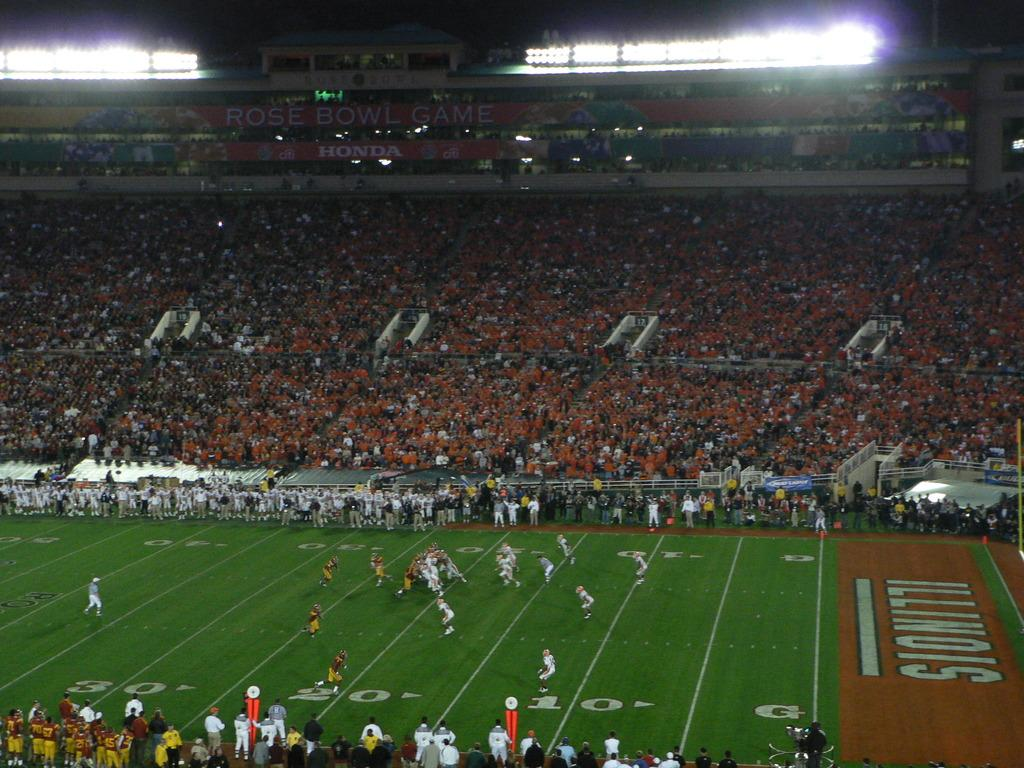<image>
Create a compact narrative representing the image presented. Football game is on at the 30 yard line on a field that says Illinois. 